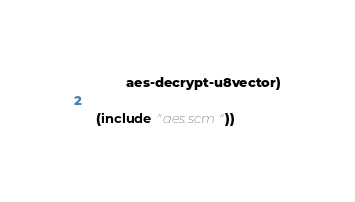Convert code to text. <code><loc_0><loc_0><loc_500><loc_500><_Scheme_>          aes-decrypt-u8vector)

  (include "aes.scm"))
</code> 